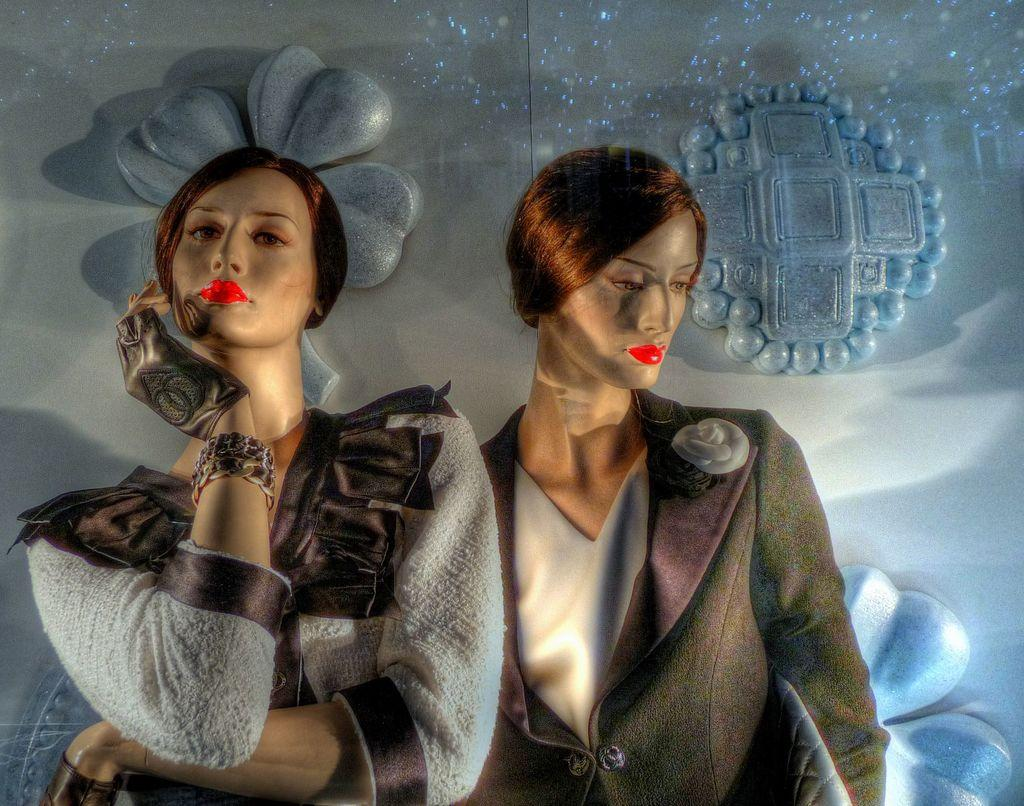What type of image is being described? The image is an animated picture. Who or what can be seen in the image? There are women in the image. What is visible in the background of the image? There is a design wall in the background of the image. What type of vegetable is being cooked in the image? There is no vegetable or cooking activity present in the image. 